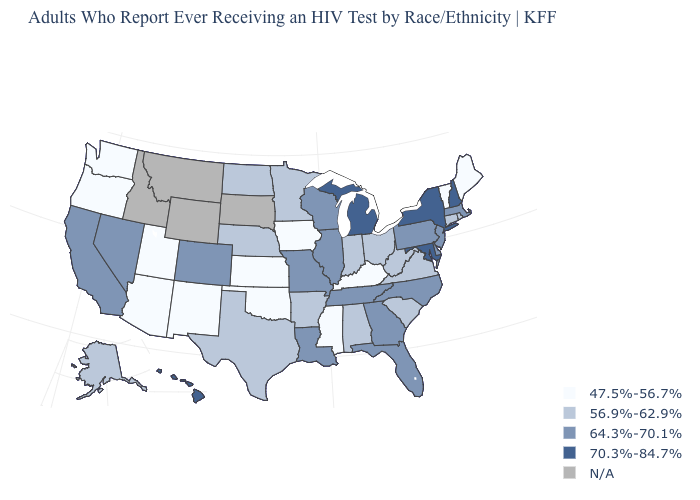Which states hav the highest value in the MidWest?
Write a very short answer. Michigan. What is the value of Michigan?
Quick response, please. 70.3%-84.7%. What is the value of Colorado?
Quick response, please. 64.3%-70.1%. Which states have the lowest value in the South?
Quick response, please. Kentucky, Mississippi, Oklahoma. What is the value of New Mexico?
Concise answer only. 47.5%-56.7%. Name the states that have a value in the range 56.9%-62.9%?
Concise answer only. Alabama, Alaska, Arkansas, Connecticut, Indiana, Minnesota, Nebraska, North Dakota, Ohio, Rhode Island, South Carolina, Texas, Virginia, West Virginia. What is the value of North Carolina?
Write a very short answer. 64.3%-70.1%. Name the states that have a value in the range 47.5%-56.7%?
Give a very brief answer. Arizona, Iowa, Kansas, Kentucky, Maine, Mississippi, New Mexico, Oklahoma, Oregon, Utah, Vermont, Washington. What is the value of Wisconsin?
Write a very short answer. 64.3%-70.1%. Among the states that border Arizona , does Nevada have the highest value?
Quick response, please. Yes. What is the lowest value in states that border Georgia?
Keep it brief. 56.9%-62.9%. Does California have the lowest value in the West?
Keep it brief. No. Name the states that have a value in the range 70.3%-84.7%?
Concise answer only. Hawaii, Maryland, Michigan, New Hampshire, New York. What is the value of Alaska?
Be succinct. 56.9%-62.9%. 